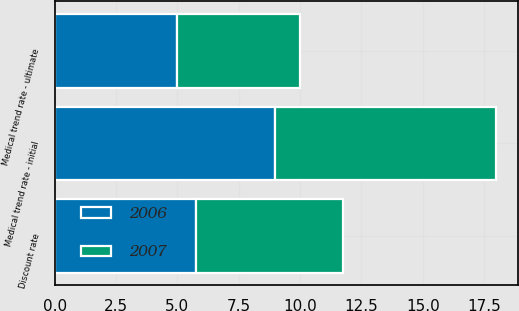<chart> <loc_0><loc_0><loc_500><loc_500><stacked_bar_chart><ecel><fcel>Discount rate<fcel>Medical trend rate - initial<fcel>Medical trend rate - ultimate<nl><fcel>2007<fcel>6<fcel>9<fcel>5<nl><fcel>2006<fcel>5.75<fcel>9<fcel>5<nl></chart> 